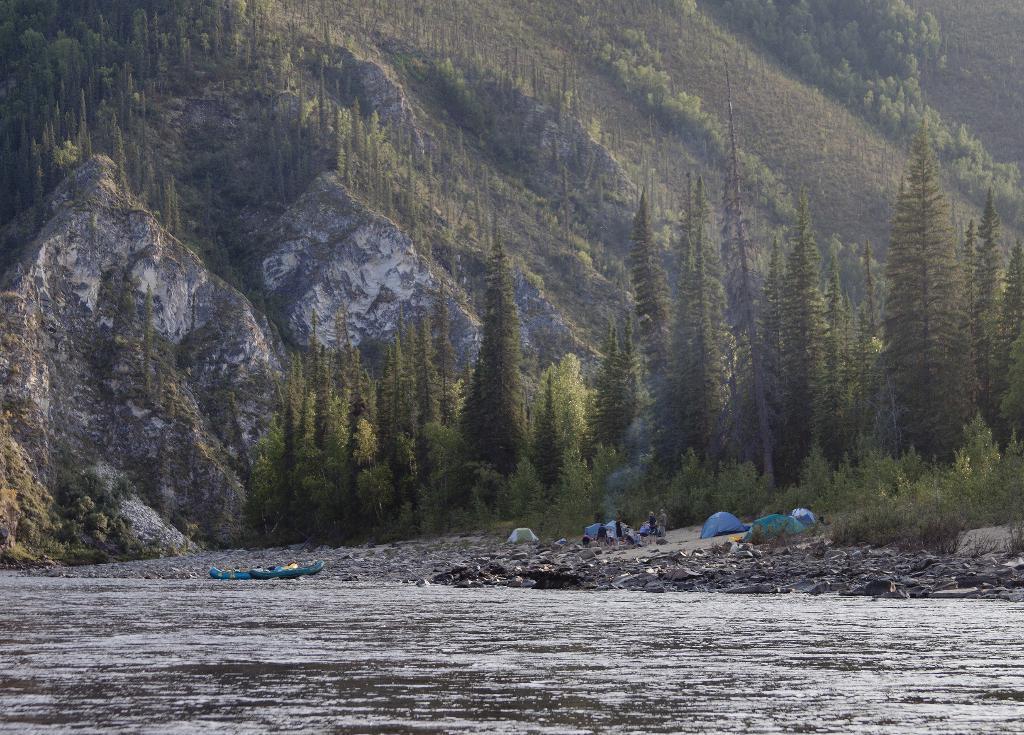In one or two sentences, can you explain what this image depicts? This picture is clicked outside. In the foreground we can see a water body. In the center we can see the tents, group of persons and some other objects and we can see the trees, plants and hills. 